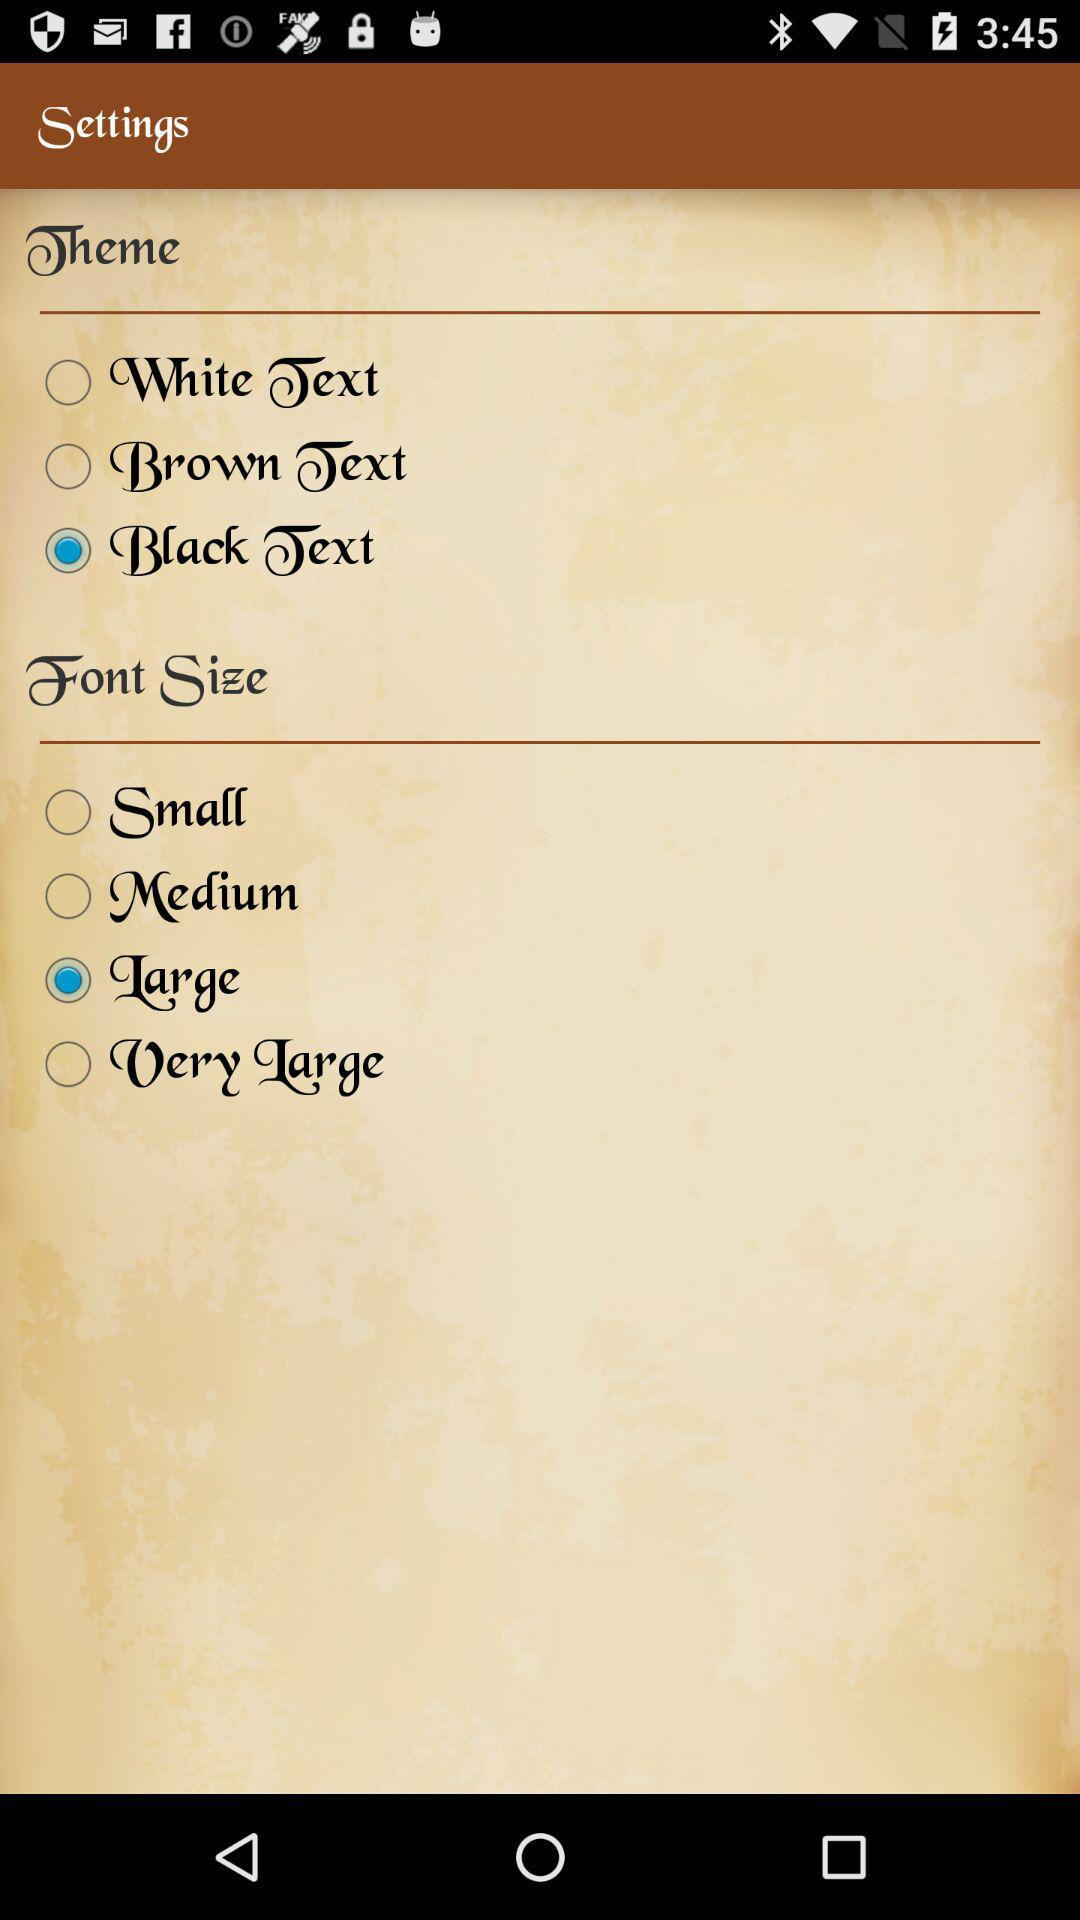What is the selected "Font Size"? The selected font size is "Large". 